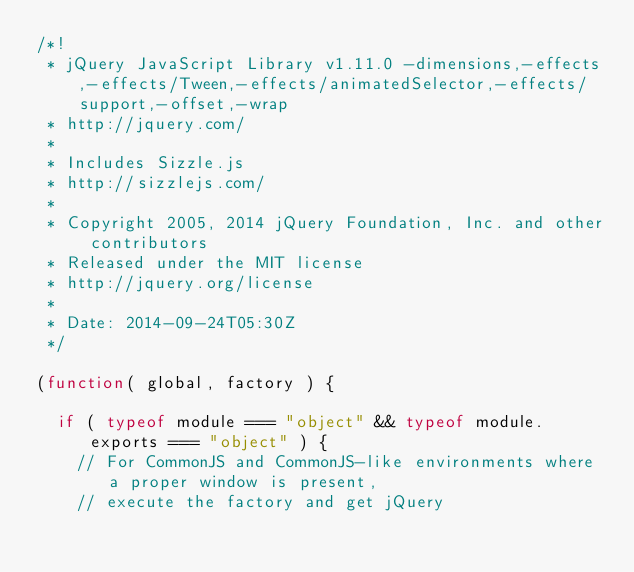<code> <loc_0><loc_0><loc_500><loc_500><_JavaScript_>/*!
 * jQuery JavaScript Library v1.11.0 -dimensions,-effects,-effects/Tween,-effects/animatedSelector,-effects/support,-offset,-wrap
 * http://jquery.com/
 *
 * Includes Sizzle.js
 * http://sizzlejs.com/
 *
 * Copyright 2005, 2014 jQuery Foundation, Inc. and other contributors
 * Released under the MIT license
 * http://jquery.org/license
 *
 * Date: 2014-09-24T05:30Z
 */

(function( global, factory ) {

	if ( typeof module === "object" && typeof module.exports === "object" ) {
		// For CommonJS and CommonJS-like environments where a proper window is present,
		// execute the factory and get jQuery</code> 